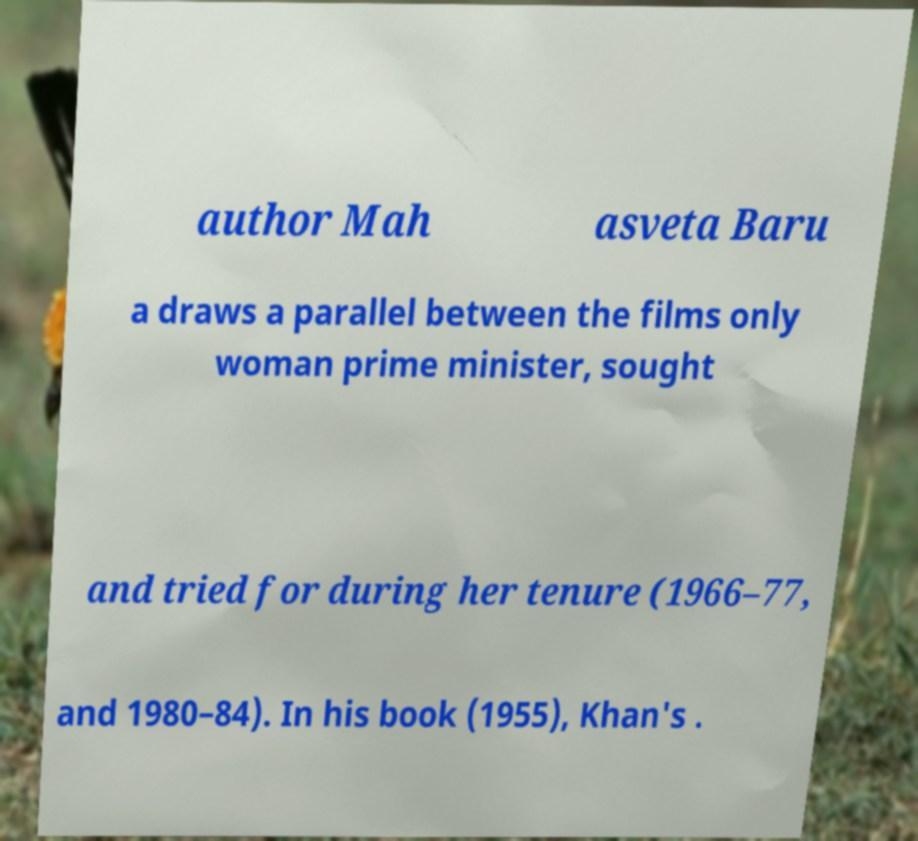What messages or text are displayed in this image? I need them in a readable, typed format. author Mah asveta Baru a draws a parallel between the films only woman prime minister, sought and tried for during her tenure (1966–77, and 1980–84). In his book (1955), Khan's . 